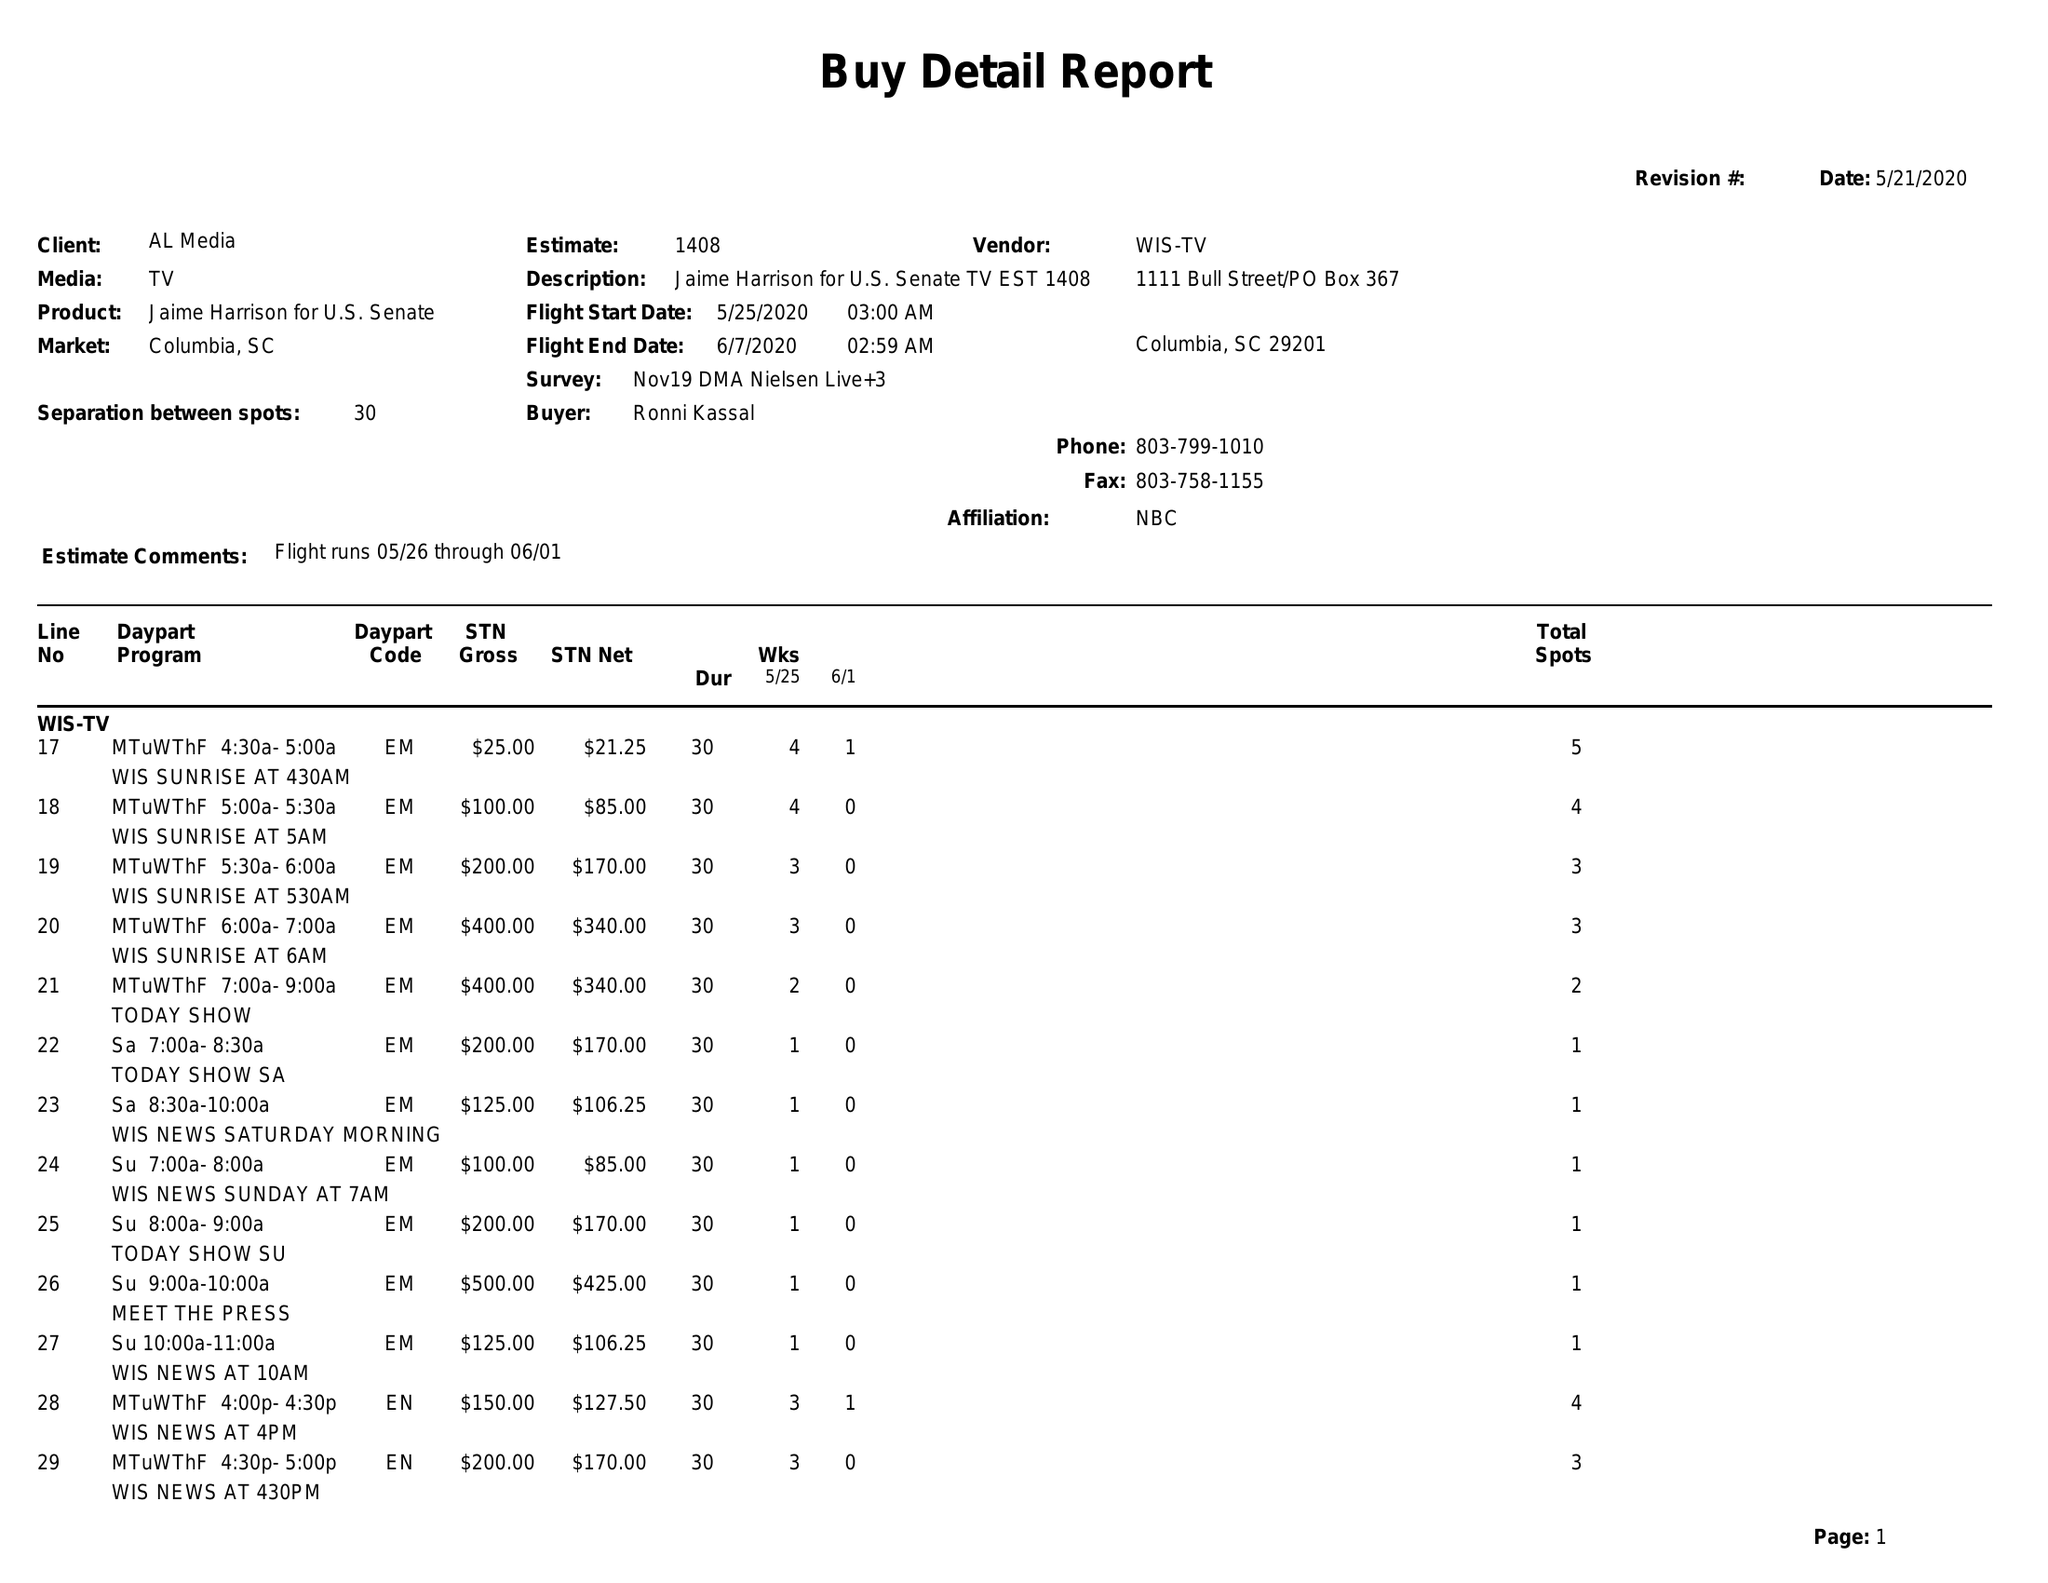What is the value for the gross_amount?
Answer the question using a single word or phrase. 16370.00 